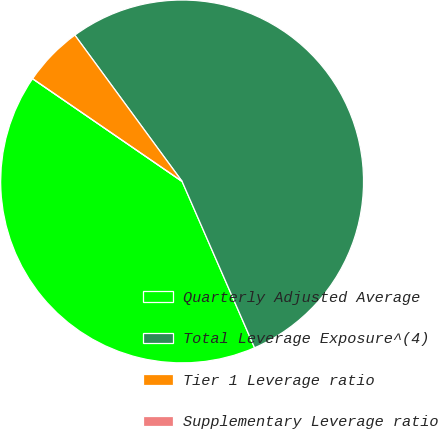<chart> <loc_0><loc_0><loc_500><loc_500><pie_chart><fcel>Quarterly Adjusted Average<fcel>Total Leverage Exposure^(4)<fcel>Tier 1 Leverage ratio<fcel>Supplementary Leverage ratio<nl><fcel>41.12%<fcel>53.53%<fcel>5.35%<fcel>0.0%<nl></chart> 